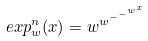<formula> <loc_0><loc_0><loc_500><loc_500>e x p _ { w } ^ { n } ( x ) = w ^ { w ^ { - ^ { - ^ { w ^ { x } } } } }</formula> 